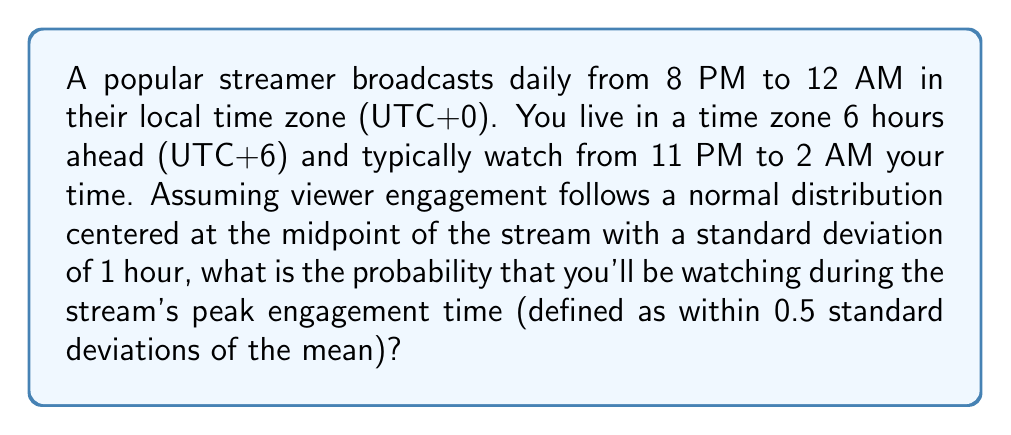Could you help me with this problem? Let's approach this step-by-step:

1) First, we need to determine the midpoint of the stream in the streamer's time zone:
   Stream duration: 8 PM to 12 AM = 4 hours
   Midpoint: 10 PM (UTC+0)

2) Convert the midpoint to your time zone:
   10 PM (UTC+0) = 4 AM (UTC+6)

3) Your viewing time in UTC+0:
   11 PM to 2 AM (UTC+6) = 5 PM to 8 PM (UTC+0)

4) The normal distribution is centered at 10 PM (UTC+0) with σ = 1 hour.

5) We want to find the probability of being within 0.5σ of the mean. In a normal distribution, this is equivalent to finding the area between z-scores of -0.5 and 0.5.

6) To calculate z-scores for your viewing time:
   z1 = (5 PM - 10 PM) / 1 hour = -5
   z2 = (8 PM - 10 PM) / 1 hour = -2

7) The probability of being within 0.5σ of the mean is:
   P(-0.5 < Z < 0.5) = Φ(0.5) - Φ(-0.5)
   where Φ is the standard normal cumulative distribution function.

8) Using a standard normal table or calculator:
   Φ(0.5) ≈ 0.6915
   Φ(-0.5) ≈ 0.3085

9) Therefore, P(-0.5 < Z < 0.5) = 0.6915 - 0.3085 = 0.3830

This represents the probability of watching during peak engagement if you were to watch the entire stream. However, you only watch from z = -5 to z = -2.

10) Since your entire viewing period is outside the peak engagement time, the probability of watching during peak engagement is 0.
Answer: 0 